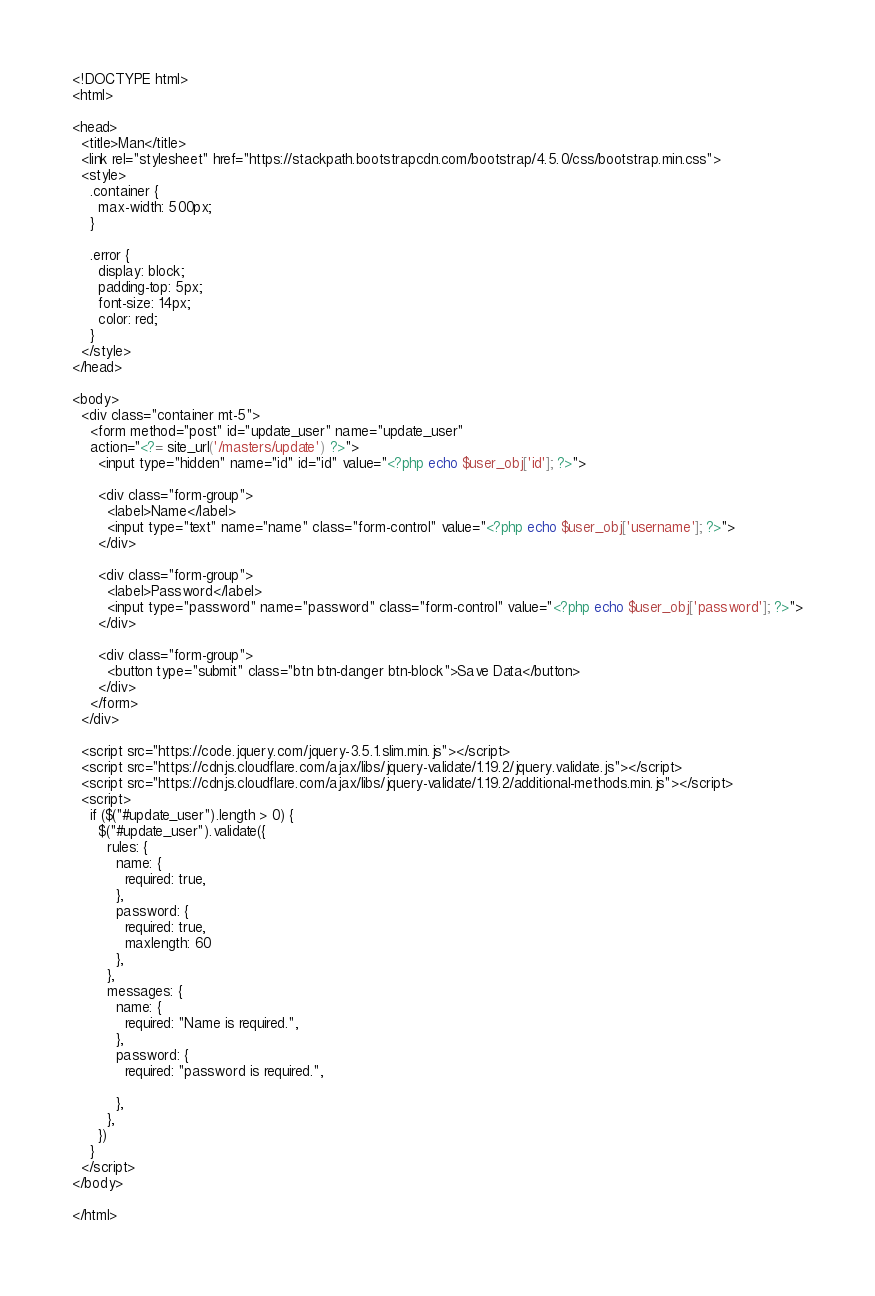Convert code to text. <code><loc_0><loc_0><loc_500><loc_500><_PHP_><!DOCTYPE html>
<html>

<head>
  <title>Man</title>
  <link rel="stylesheet" href="https://stackpath.bootstrapcdn.com/bootstrap/4.5.0/css/bootstrap.min.css">
  <style>
    .container {
      max-width: 500px;
    }

    .error {
      display: block;
      padding-top: 5px;
      font-size: 14px;
      color: red;
    }
  </style>
</head>

<body>
  <div class="container mt-5">
    <form method="post" id="update_user" name="update_user" 
    action="<?= site_url('/masters/update') ?>">
      <input type="hidden" name="id" id="id" value="<?php echo $user_obj['id']; ?>">

      <div class="form-group">
        <label>Name</label>
        <input type="text" name="name" class="form-control" value="<?php echo $user_obj['username']; ?>">
      </div>

      <div class="form-group">
        <label>Password</label>
        <input type="password" name="password" class="form-control" value="<?php echo $user_obj['password']; ?>">
      </div>

      <div class="form-group">
        <button type="submit" class="btn btn-danger btn-block">Save Data</button>
      </div>
    </form>
  </div>

  <script src="https://code.jquery.com/jquery-3.5.1.slim.min.js"></script>
  <script src="https://cdnjs.cloudflare.com/ajax/libs/jquery-validate/1.19.2/jquery.validate.js"></script>
  <script src="https://cdnjs.cloudflare.com/ajax/libs/jquery-validate/1.19.2/additional-methods.min.js"></script>
  <script>
    if ($("#update_user").length > 0) {
      $("#update_user").validate({
        rules: {
          name: {
            required: true,
          },
          password: {
            required: true,
            maxlength: 60
          },
        },
        messages: {
          name: {
            required: "Name is required.",
          },
          password: {
            required: "password is required.",
           
          },
        },
      })
    }
  </script>
</body>

</html></code> 